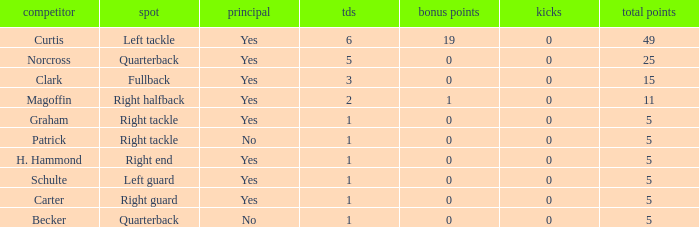Name the extra points for left guard 0.0. 